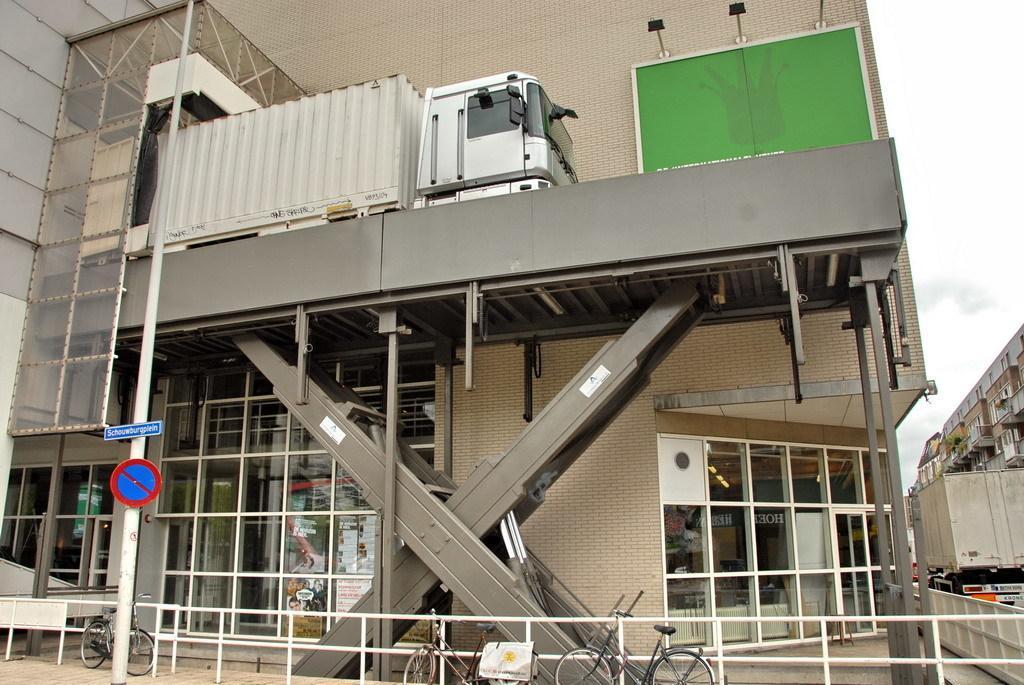Could you give a brief overview of what you see in this image? At the bottom of the picture there are bicycles, railing, board and a pole. In the middle of the picture we can see buildings, trucks, board, wall and other objects. At the top towards right there is sky. 